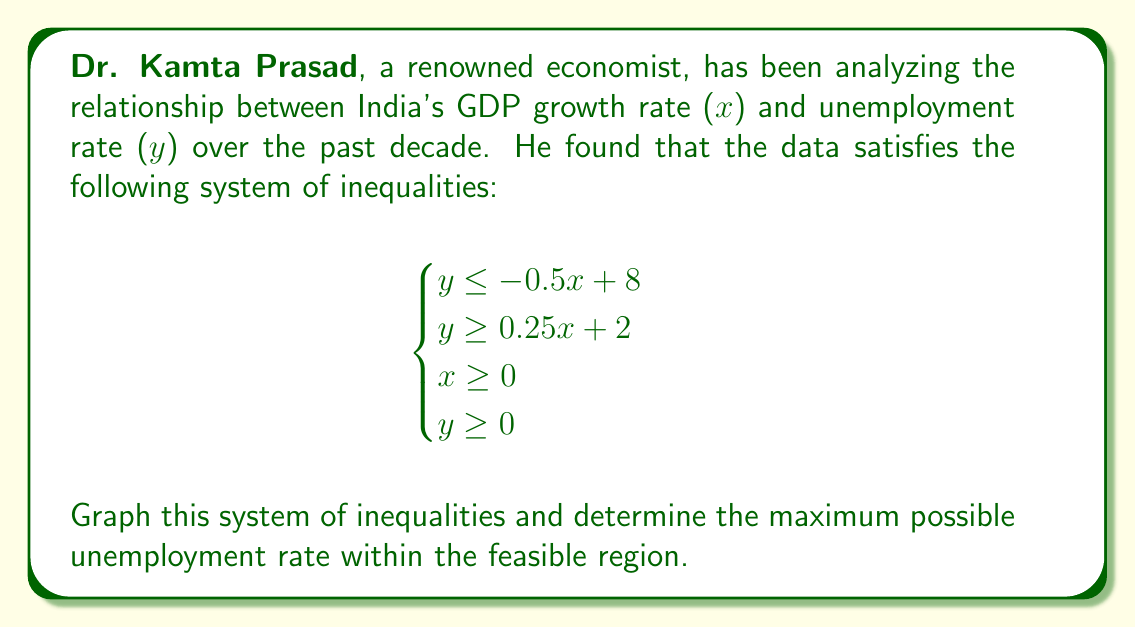Solve this math problem. To solve this problem, we'll follow these steps:

1) First, let's graph each inequality:

   a) $y \leq -0.5x + 8$ : This is a line with y-intercept 8 and slope -0.5.
   b) $y \geq 0.25x + 2$ : This is a line with y-intercept 2 and slope 0.25.
   c) $x \geq 0$ : This is the y-axis.
   d) $y \geq 0$ : This is the x-axis.

2) Now, let's shade the regions that satisfy each inequality:

   a) Shade below $y = -0.5x + 8$
   b) Shade above $y = 0.25x + 2$
   c) Shade to the right of the y-axis
   d) Shade above the x-axis

3) The region that satisfies all inequalities is the intersection of these shaded regions.

4) To find the maximum possible unemployment rate (y), we need to find the highest point in the feasible region.

5) This point will be at the intersection of $y = -0.5x + 8$ and $y = 0.25x + 2$

6) To find this point, solve the system:

   $-0.5x + 8 = 0.25x + 2$
   $6 = 0.75x$
   $x = 8$

   Substituting this x-value into either equation:
   $y = -0.5(8) + 8 = 4$

7) Therefore, the point of intersection is (8, 4).

[asy]
unitsize(1cm);
draw((-1,0)--(10,0),arrow=Arrow(TeXHead));
draw((0,-1)--(0,9),arrow=Arrow(TeXHead));
draw((0,8)--(16,0),blue);
draw((0,2)--(24,8),red);
fill((0,0)--(0,8)--(8,4)--(8,0)--cycle,palegreen);
label("x",(10,0),E);
label("y",(0,9),N);
label("y = -0.5x + 8",(12,2),NE,blue);
label("y = 0.25x + 2",(12,5),NW,red);
dot((8,4));
label("(8, 4)",(8,4),NE);
[/asy]

8) The maximum unemployment rate in the feasible region is 4%.
Answer: 4% 